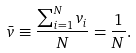<formula> <loc_0><loc_0><loc_500><loc_500>\bar { v } \equiv \frac { \sum ^ { N } _ { i = 1 } v _ { i } } { N } = \frac { 1 } { N } .</formula> 